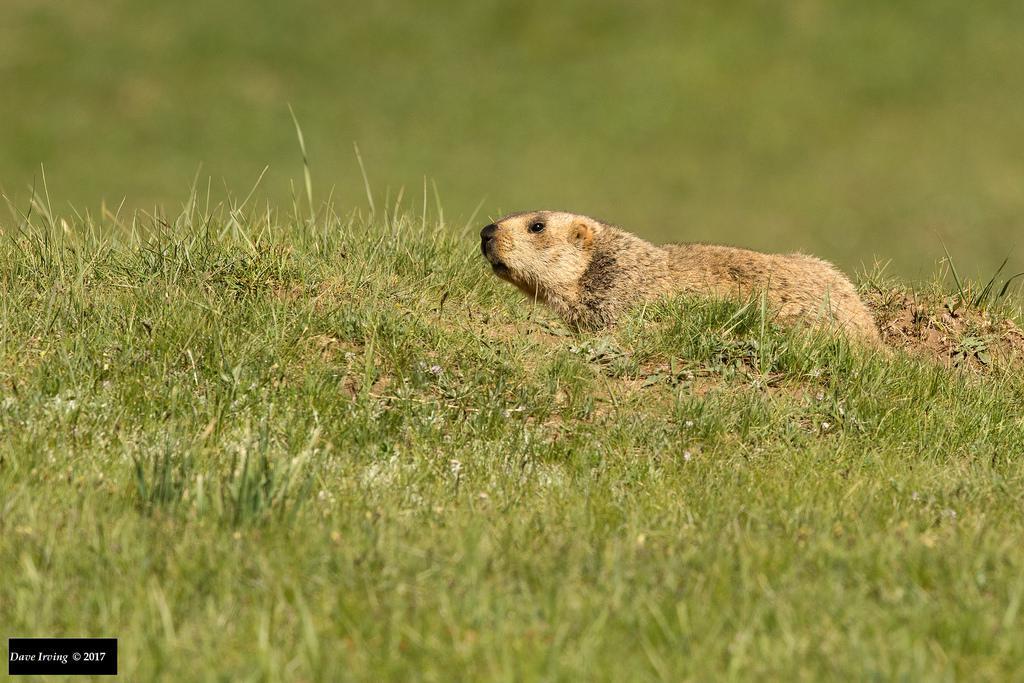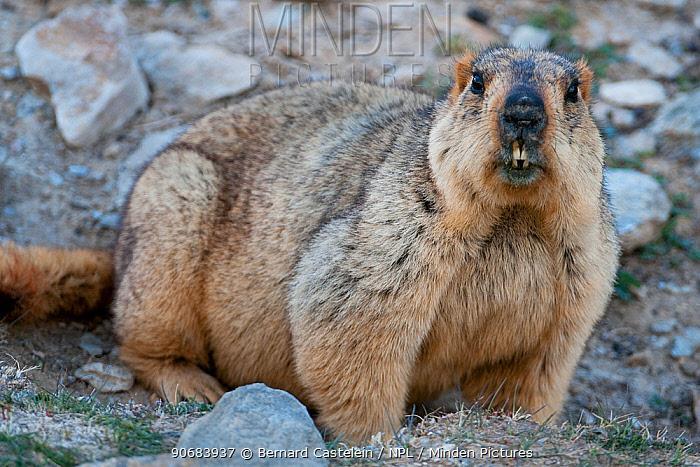The first image is the image on the left, the second image is the image on the right. Evaluate the accuracy of this statement regarding the images: "There are more animals in the image on the left.". Is it true? Answer yes or no. No. The first image is the image on the left, the second image is the image on the right. Considering the images on both sides, is "The combined images include at least two marmots with their heads raised and gazing leftward." valid? Answer yes or no. No. 